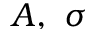<formula> <loc_0><loc_0><loc_500><loc_500>A , \ \sigma</formula> 